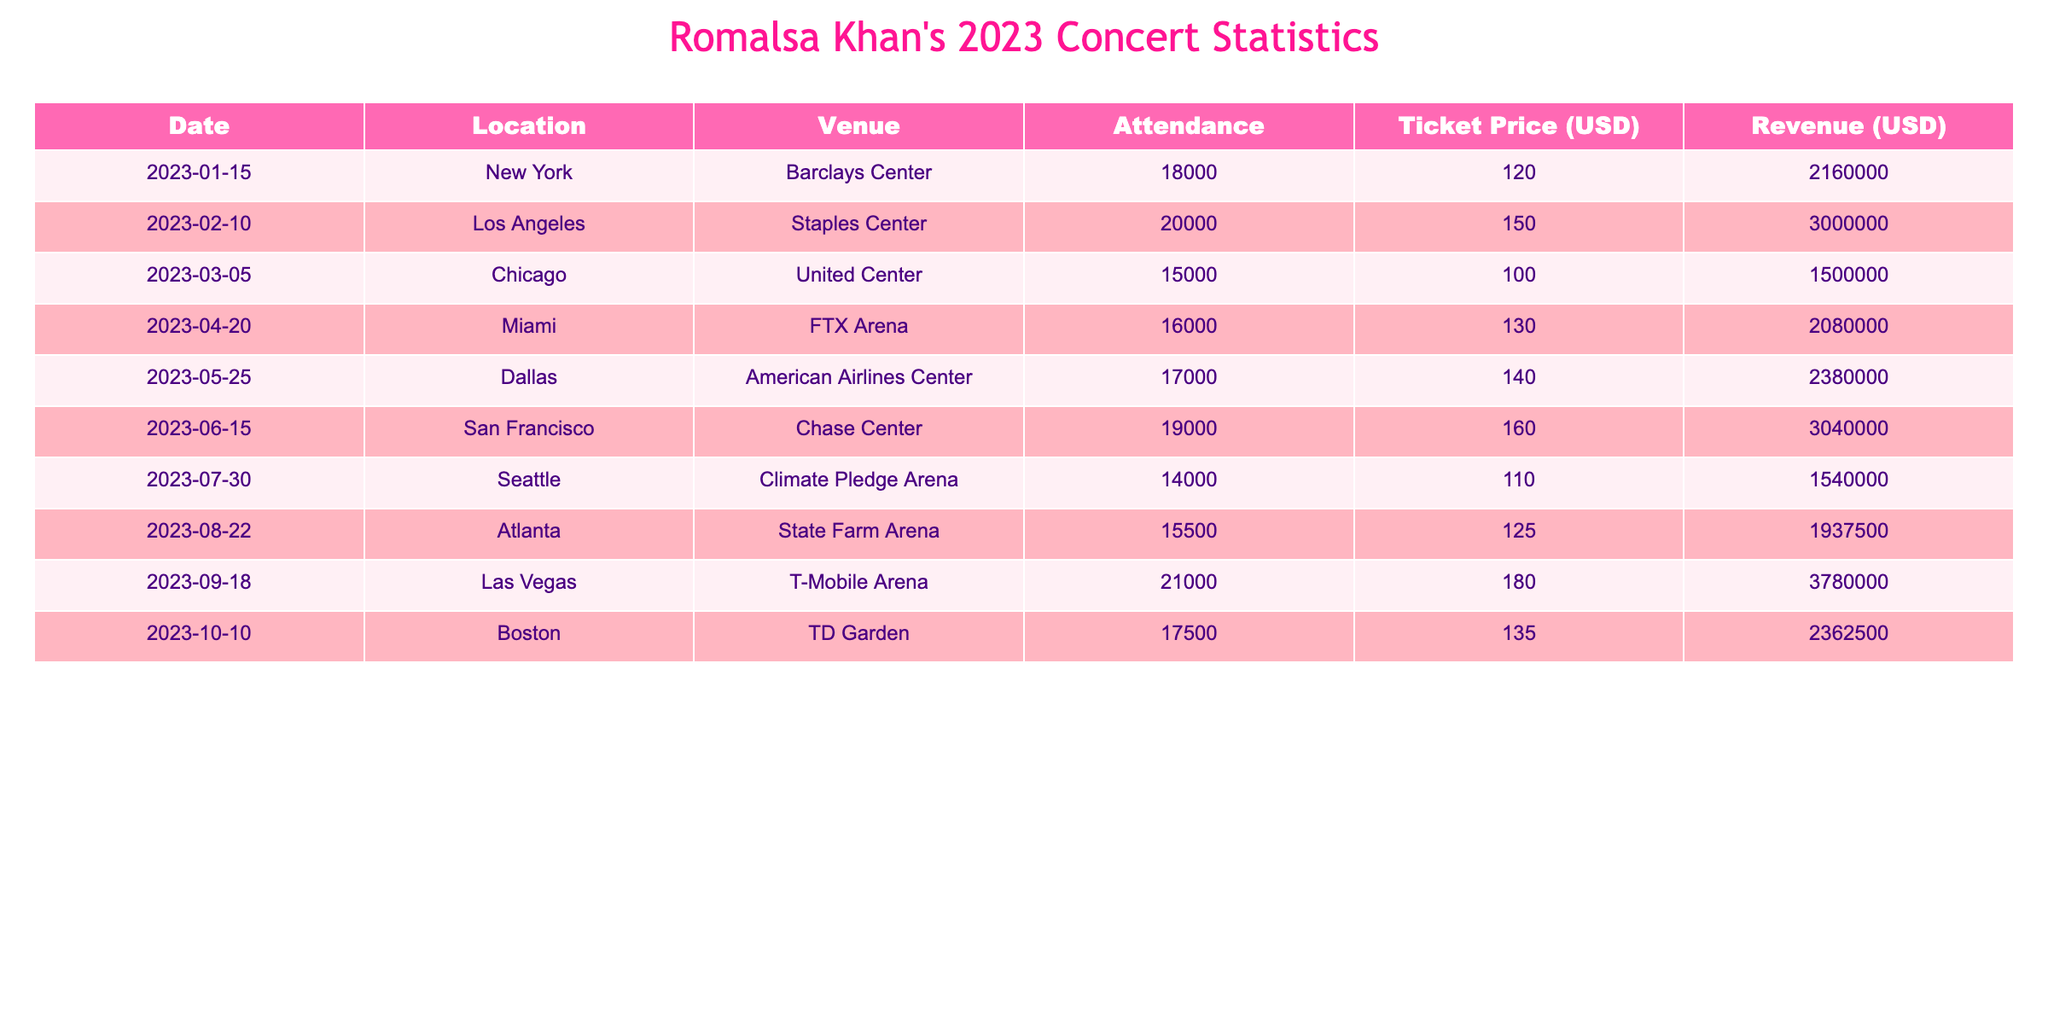What was the attendance at the Los Angeles concert? The specific attendance figure for the Los Angeles concert on February 10, 2023, is listed directly in the table. It states that the attendance was 20,000.
Answer: 20,000 What was the highest ticket price for Romalsa Khan's concerts in 2023? Reviewing the ticket prices from each concert in the table, we see that the highest ticket price is $180, which corresponds to the Las Vegas concert on September 18, 2023.
Answer: 180 Which location had the lowest attendance? By comparing the attendance figures across all concerts, we find that Seattle had the lowest attendance of 14,000 on July 30, 2023.
Answer: Seattle What is the total revenue generated from all concerts? To find the total revenue, we sum the revenue figures from each concert: 2,160,000 + 3,000,000 + 1,500,000 + 2,080,000 + 2,380,000 + 3,040,000 + 1,540,000 + 1,937,500 + 3,780,000 + 2,362,500 = 23,979,500.
Answer: 23,979,500 Did the attendance in Chicago exceed the average attendance across all concerts? First, we note the attendance figures: (18,000 + 20,000 + 15,000 + 16,000 + 17,000 + 19,000 + 14,000 + 15,500 + 21,000 + 17,500) =  1,482,500, which gives an average of 148,250 / 10 = 14,825. Chicago's attendance was 15,000, which is greater than 14,825.
Answer: Yes What percentage of the total attendance came from the New York concert? Total attendance is 149,500. The New York concert had an attendance of 18,000. The percentage is (18,000 / 149,500) * 100 = 12.05%.
Answer: 12.05% How many concerts had an attendance greater than 15,000? By examining each attendance figure, we find the concerts with attendance greater than 15,000 are New York, Los Angeles, Miami, Dallas, San Francisco, Atlanta, Las Vegas, and Boston. This makes a total of 8 concerts.
Answer: 8 What was the average revenue generated per concert? To calculate the average revenue, we sum all the revenue values and divide by the number of concerts: (2,160,000 + 3,000,000 + 1,500,000 + 2,080,000 + 2,380,000 + 3,040,000 + 1,540,000 + 1,937,500 + 3,780,000 + 2,362,500) / 10 = 2,397,950.
Answer: 2,397,950 Which concert had the highest revenue, and what was that revenue? The highest revenue listed in the table is for the Las Vegas concert on September 18, 2023, with a revenue of $3,780,000.
Answer: Las Vegas, 3,780,000 